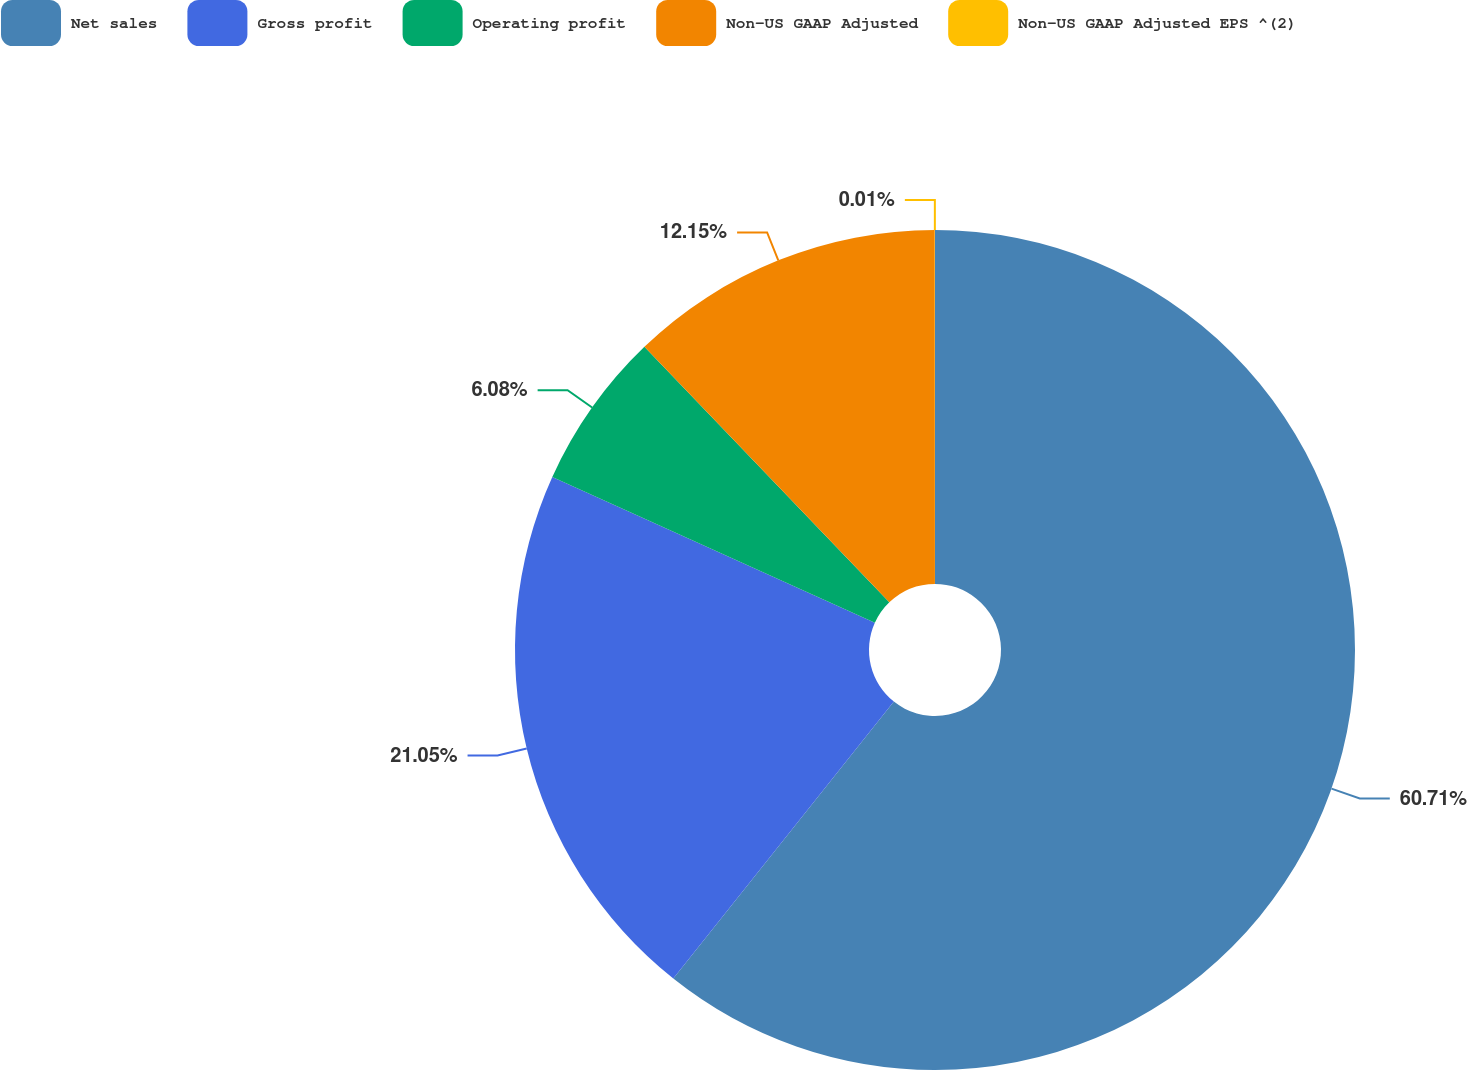<chart> <loc_0><loc_0><loc_500><loc_500><pie_chart><fcel>Net sales<fcel>Gross profit<fcel>Operating profit<fcel>Non-US GAAP Adjusted<fcel>Non-US GAAP Adjusted EPS ^(2)<nl><fcel>60.7%<fcel>21.05%<fcel>6.08%<fcel>12.15%<fcel>0.01%<nl></chart> 